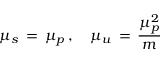Convert formula to latex. <formula><loc_0><loc_0><loc_500><loc_500>\mu _ { s } \, = \, \mu _ { p } \, , \quad \mu _ { u } \, = \, \frac { \mu _ { p } ^ { 2 } } { m }</formula> 